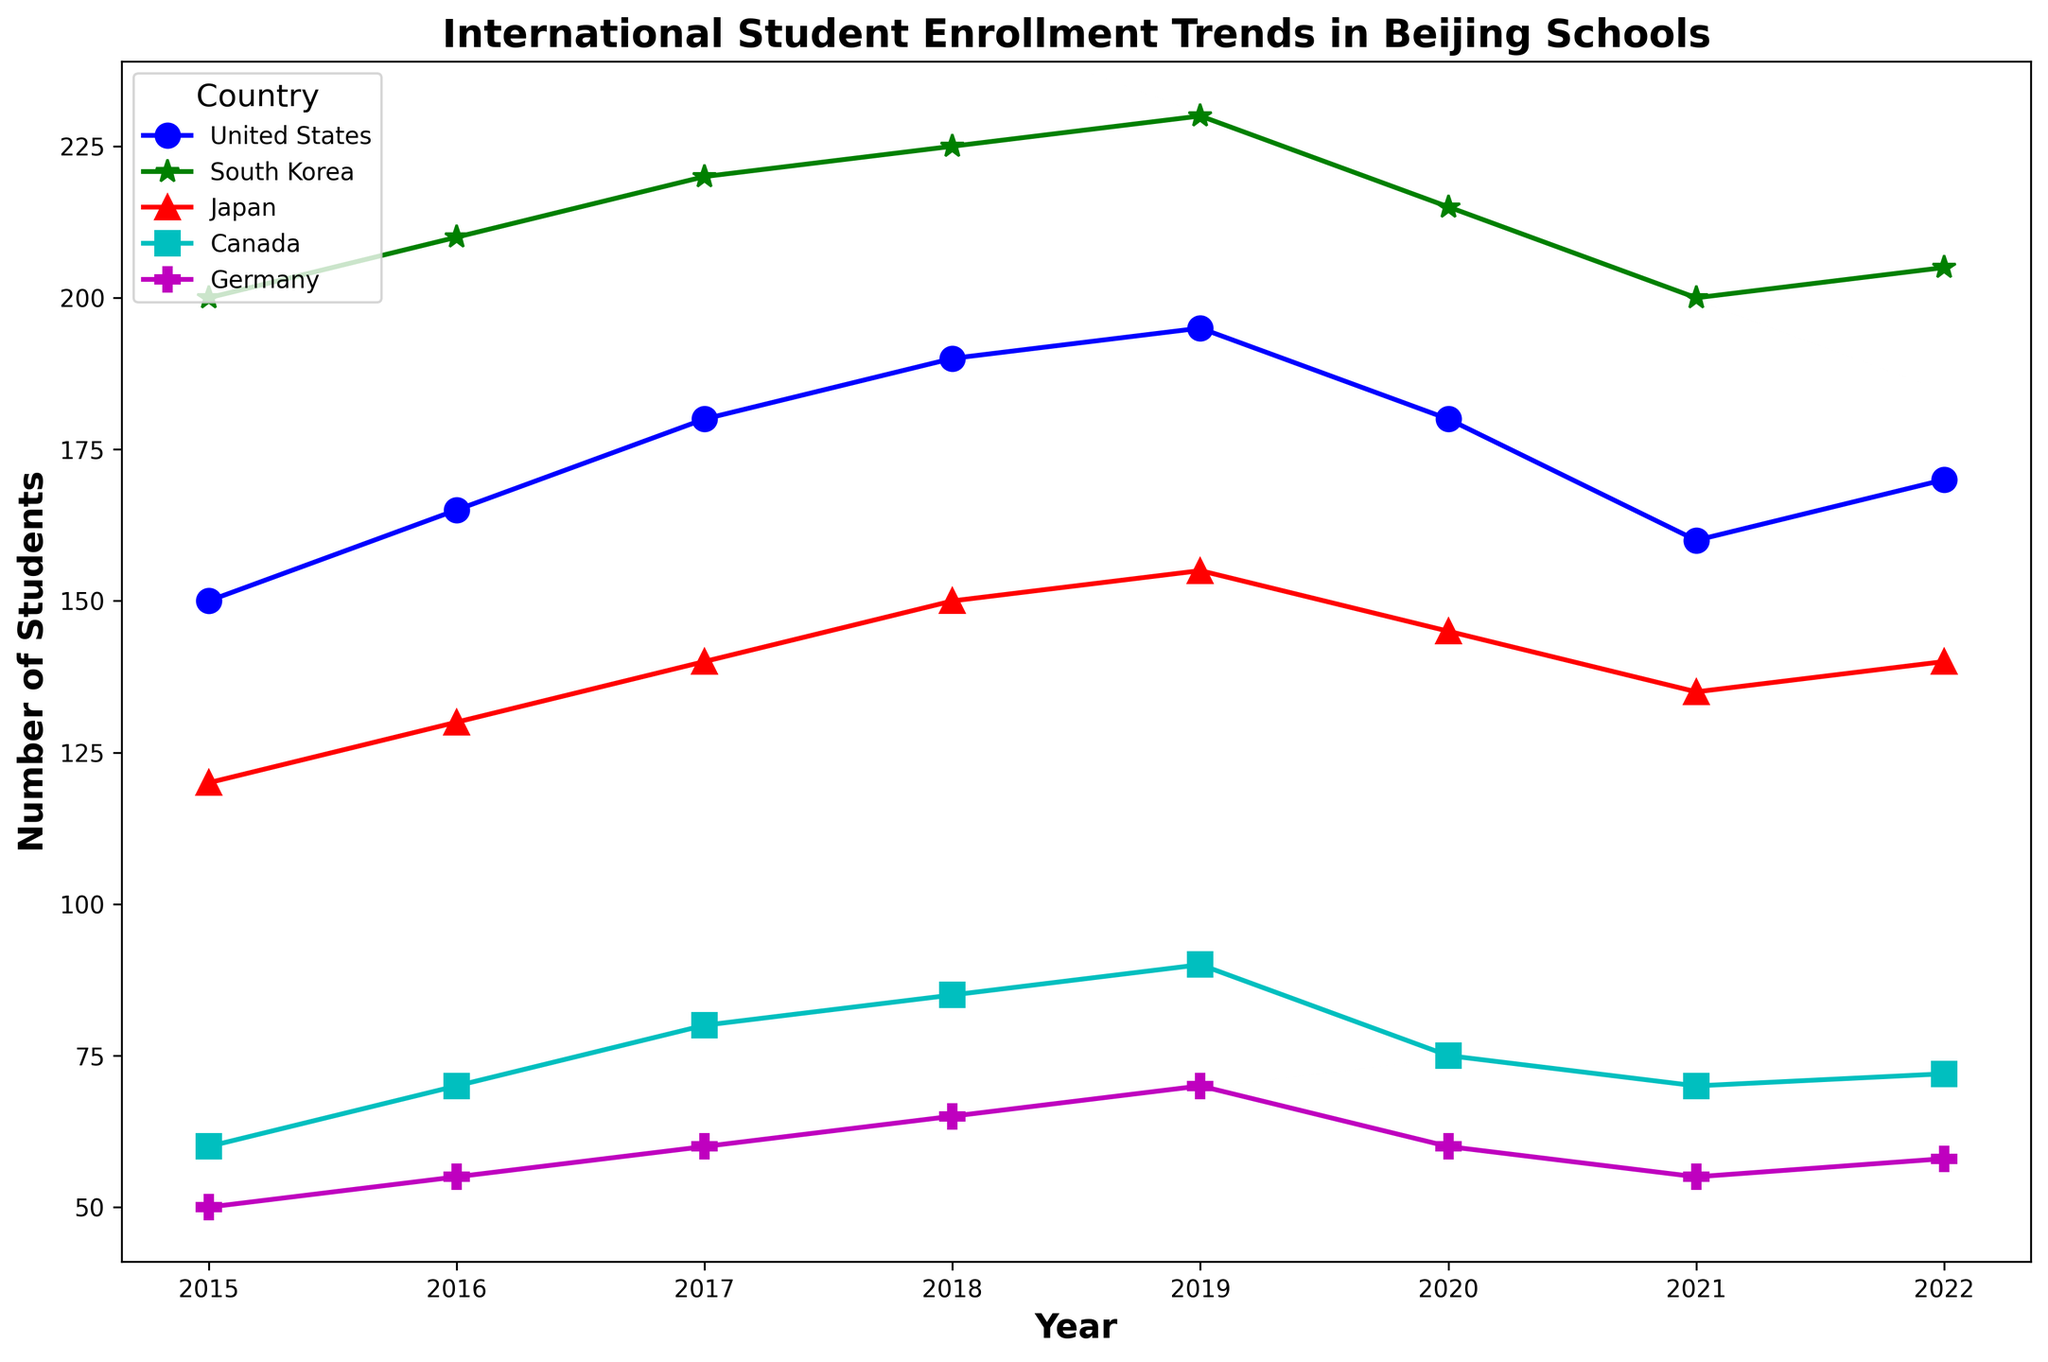Which country had the highest number of students enrolled in Beijing schools in 2015? Look at the year 2015 and identify the country with the tallest point on the plot. South Korea has the highest value.
Answer: South Korea How did the number of students from the United States change from 2019 to 2020? Look at the data points for the United States in 2019 and 2020. Note the numbers and find the difference: 195 in 2019 and 180 in 2020. This shows a decrease of 15 students.
Answer: Decreased by 15 Which two countries showed a reduction in the number of students from 2019 to 2020? Observe the trend lines between 2019 and 2020. The United States and Germany show a drop in their data points.
Answer: United States, Germany During which year did South Korea have the highest number of students enrolled, and how many students were there? Observe the peak of the South Korean trend line. The highest point is in 2019 with 230 students.
Answer: 2019, 230 students What is the total number of students from Canada enrolled in Beijing schools over the seven-year span? Sum the data points for Canada from 2015 to 2022: 60 + 70 + 80 + 85 + 90 + 75 + 70 + 72 = 602
Answer: 602 Which country's student enrollment remained the most stable over the years, and how can you tell? Compare the variation in the trend lines. Germany has the most consistent numbers without significant peaks or drops, remaining around 50-70 students throughout the years.
Answer: Germany What is the average number of students from Japan enrolled in any given year? Sum the data points for Japan and divide by the number of years: (120 + 130 + 140 + 150 + 155 + 145 + 135 + 140) / 8 = 1260 / 8 = 157.5
Answer: 157.5 In which year did the total enrollment for all countries combined reach its peak, and what was the total number of students that year? Sum the values for all countries for each year and compare. 2019 has the highest total: 195 (US) + 230 (South Korea) + 155 (Japan) + 90 (Canada) + 70 (Germany) = 740
Answer: 2019, 740 What was the average number of students enrolled per year from Germany? Sum the data points for Germany and divide by the number of years: (50 + 55 + 60 + 65 + 70 + 60 + 55 + 58) / 8 = 473 / 8 = 59.125
Answer: 59.125 